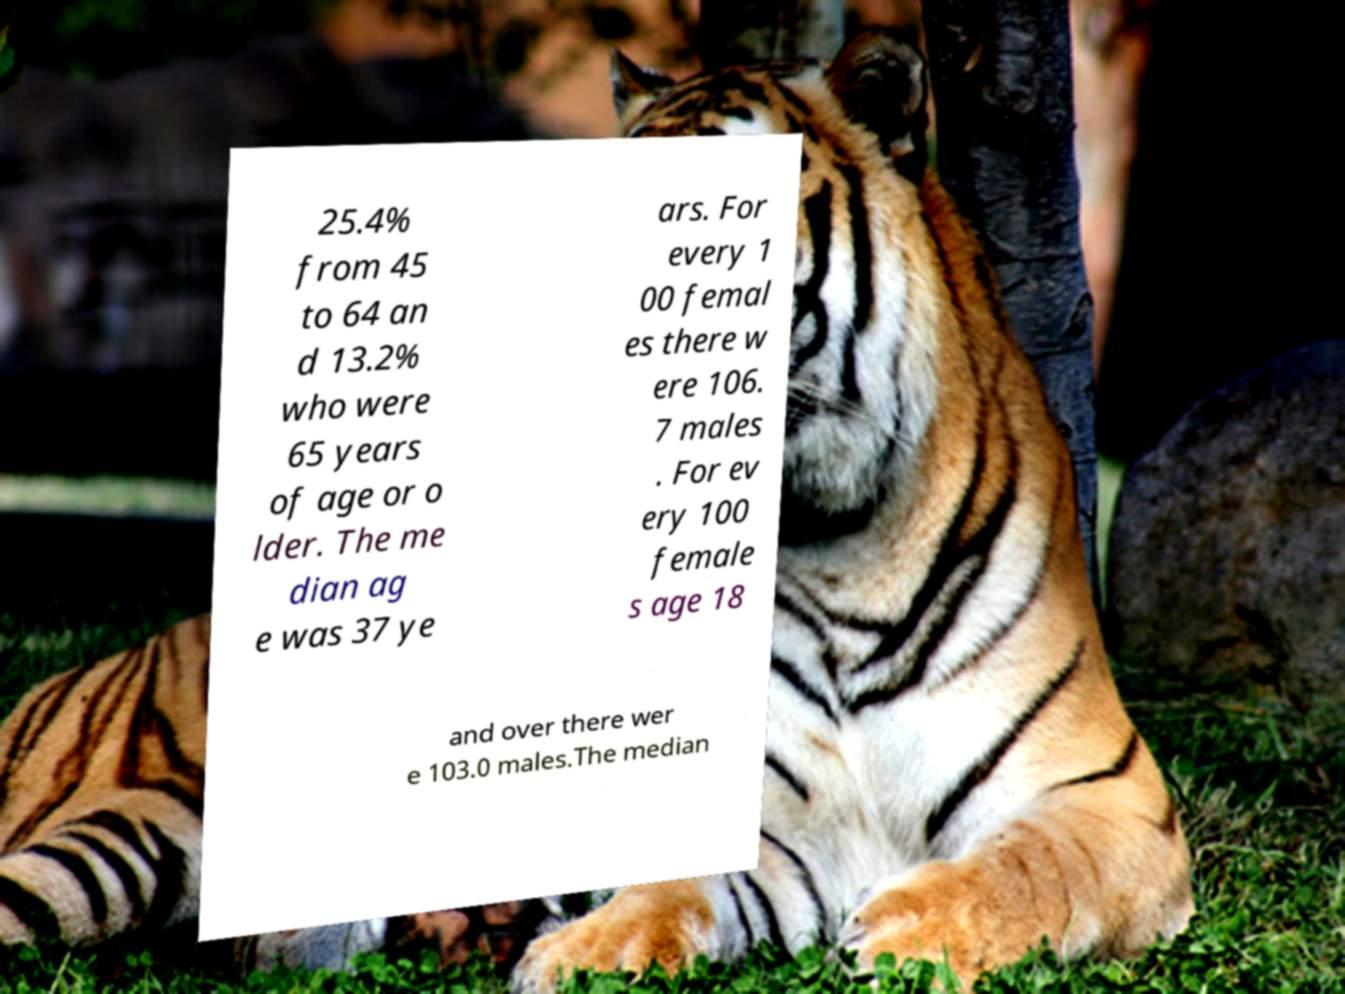Can you accurately transcribe the text from the provided image for me? 25.4% from 45 to 64 an d 13.2% who were 65 years of age or o lder. The me dian ag e was 37 ye ars. For every 1 00 femal es there w ere 106. 7 males . For ev ery 100 female s age 18 and over there wer e 103.0 males.The median 